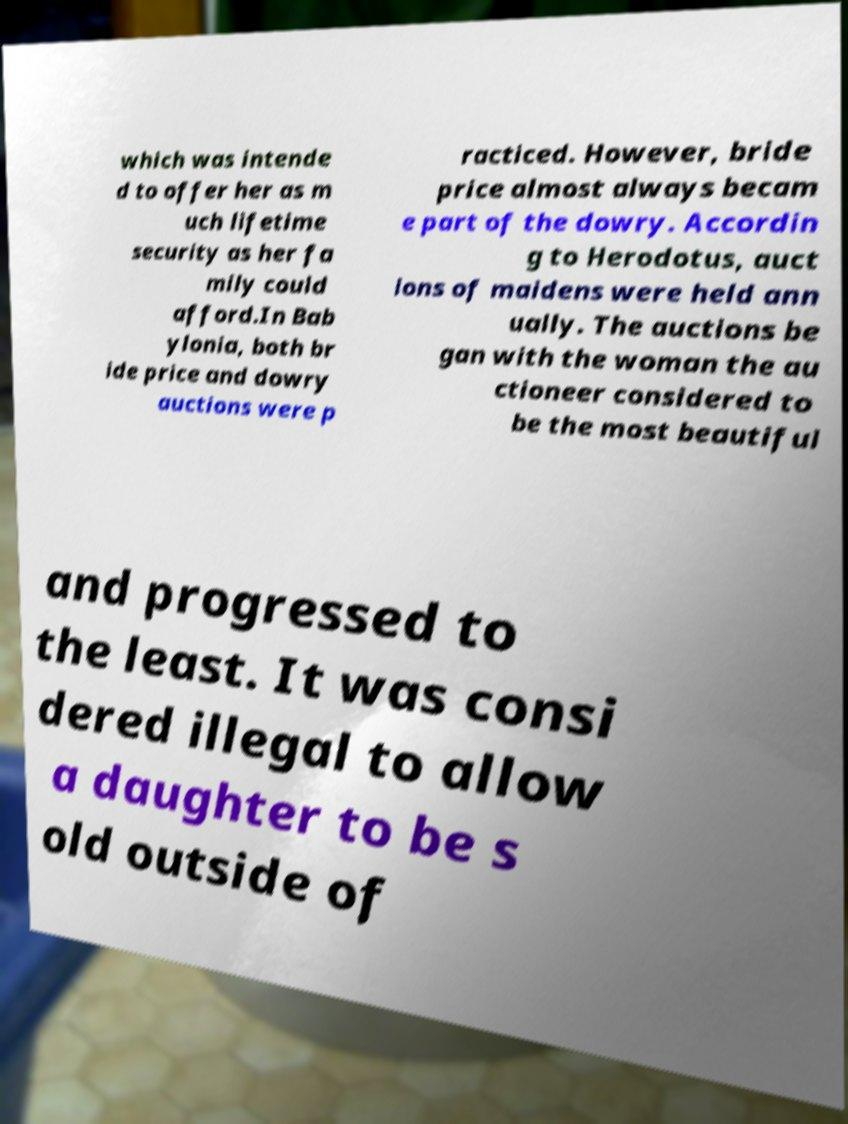Could you assist in decoding the text presented in this image and type it out clearly? which was intende d to offer her as m uch lifetime security as her fa mily could afford.In Bab ylonia, both br ide price and dowry auctions were p racticed. However, bride price almost always becam e part of the dowry. Accordin g to Herodotus, auct ions of maidens were held ann ually. The auctions be gan with the woman the au ctioneer considered to be the most beautiful and progressed to the least. It was consi dered illegal to allow a daughter to be s old outside of 